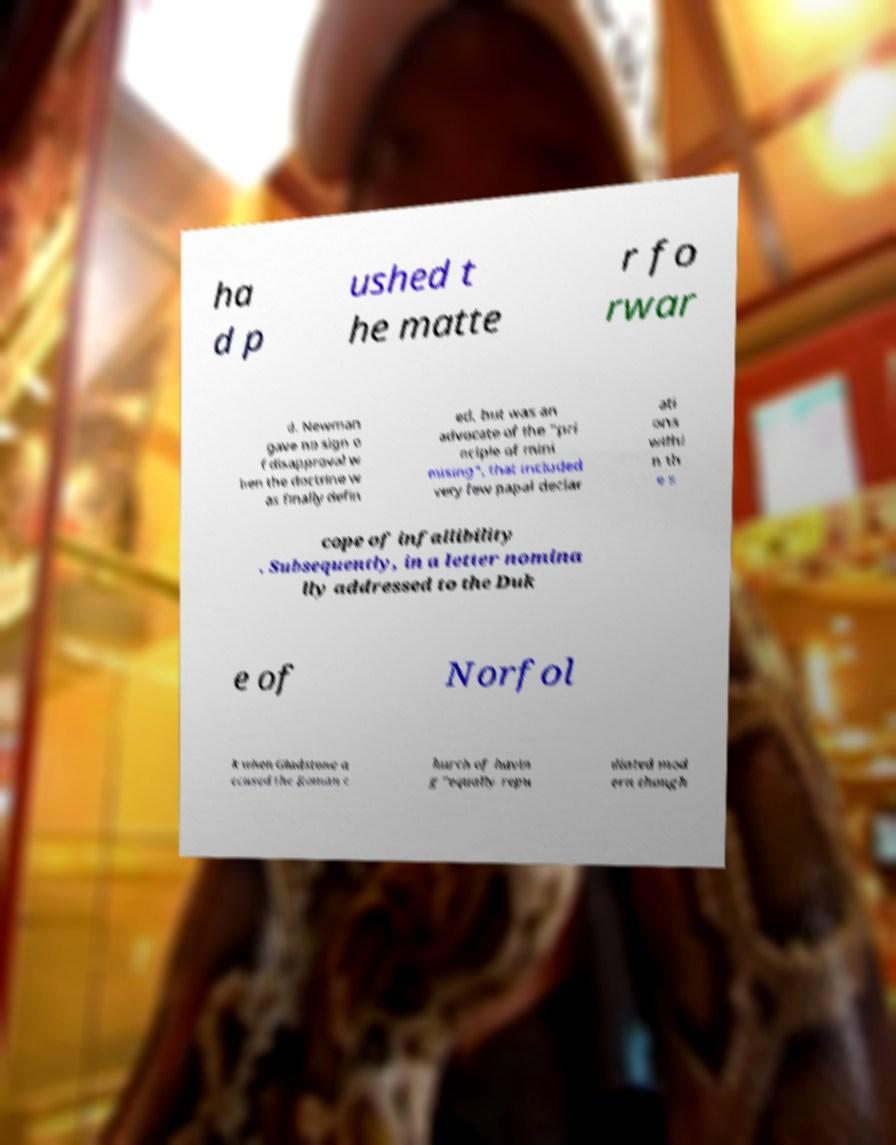Could you assist in decoding the text presented in this image and type it out clearly? ha d p ushed t he matte r fo rwar d. Newman gave no sign o f disapproval w hen the doctrine w as finally defin ed, but was an advocate of the "pri nciple of mini mising", that included very few papal declar ati ons withi n th e s cope of infallibility . Subsequently, in a letter nomina lly addressed to the Duk e of Norfol k when Gladstone a ccused the Roman c hurch of havin g "equally repu diated mod ern though 